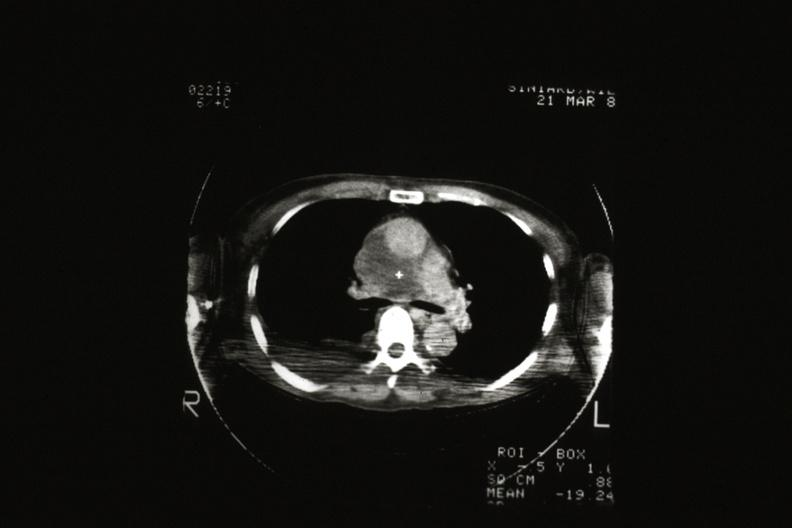s thymus present?
Answer the question using a single word or phrase. Yes 